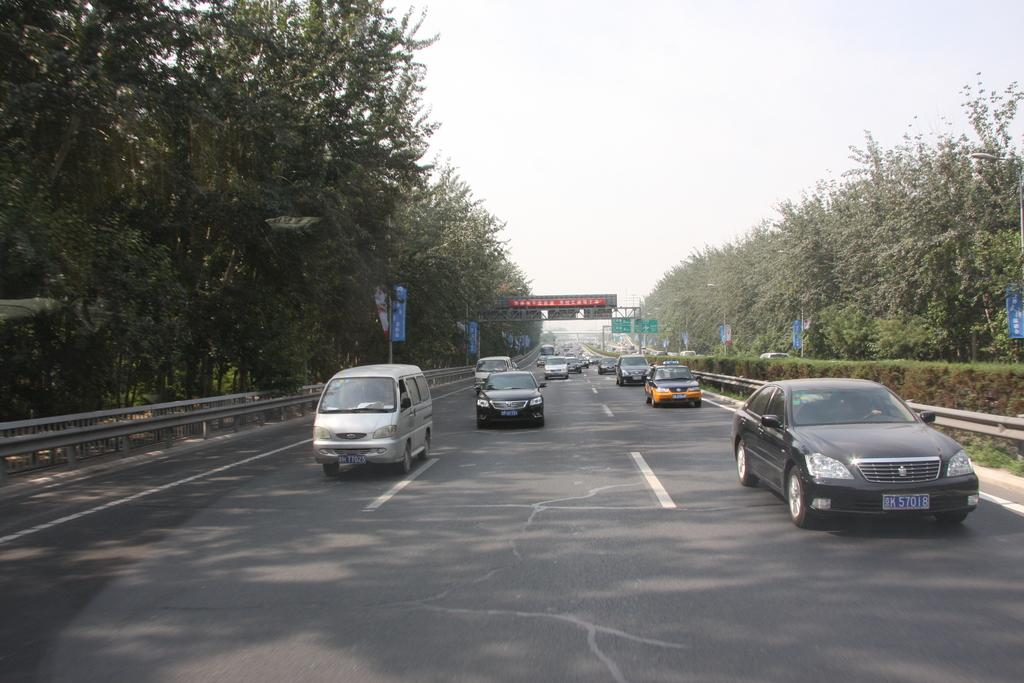What can be seen on the road in the image? There are vehicles on the road in the image. What is visible in the background of the image? There are trees and boards in the background of the image. What part of the natural environment is visible in the image? The sky is visible in the background of the image. How many fish can be seen swimming in the image? There are no fish present in the image; it features vehicles on the road and trees, boards, and the sky in the background. What type of animal is depicted on the boards in the background? There is no animal depicted on the boards in the background; the boards are not described in detail in the provided facts. 